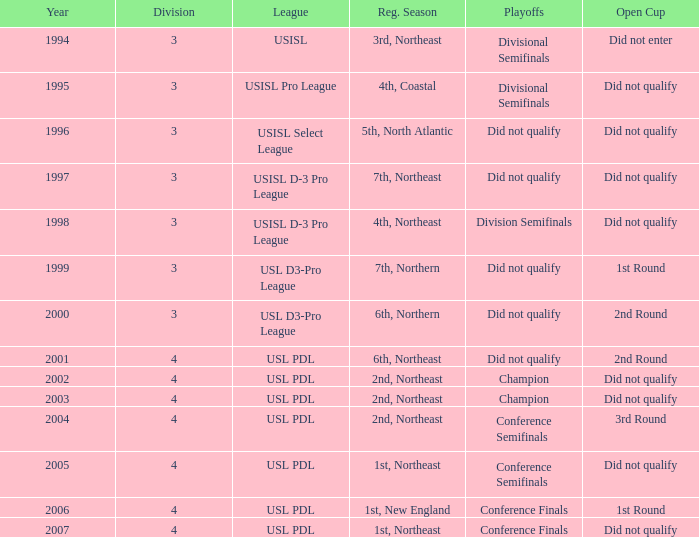Name the playoffs for  usisl select league Did not qualify. 